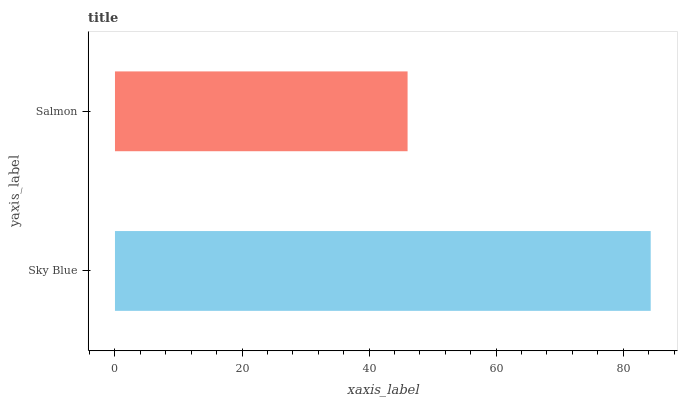Is Salmon the minimum?
Answer yes or no. Yes. Is Sky Blue the maximum?
Answer yes or no. Yes. Is Salmon the maximum?
Answer yes or no. No. Is Sky Blue greater than Salmon?
Answer yes or no. Yes. Is Salmon less than Sky Blue?
Answer yes or no. Yes. Is Salmon greater than Sky Blue?
Answer yes or no. No. Is Sky Blue less than Salmon?
Answer yes or no. No. Is Sky Blue the high median?
Answer yes or no. Yes. Is Salmon the low median?
Answer yes or no. Yes. Is Salmon the high median?
Answer yes or no. No. Is Sky Blue the low median?
Answer yes or no. No. 